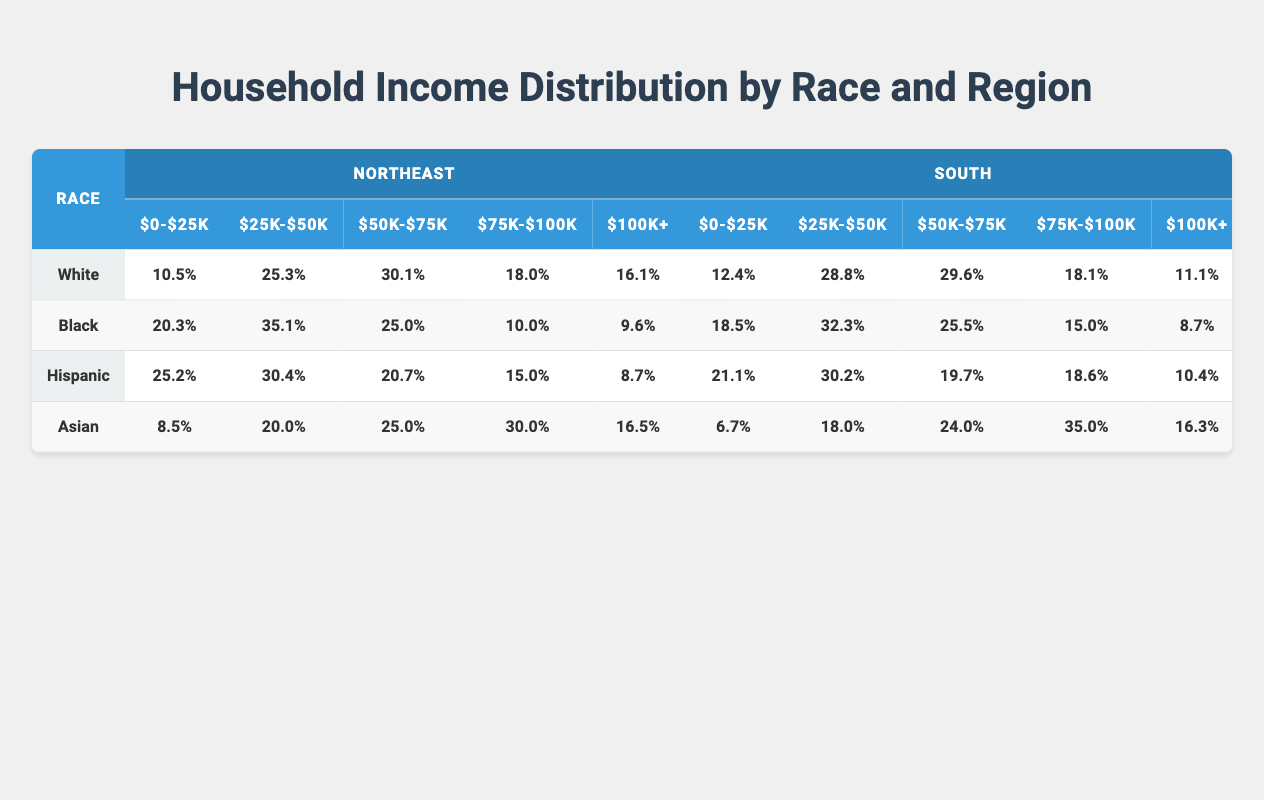What is the percentage of Black households earning $0-$25,000 in the Northeast? The table shows that Black households in the Northeast have a percentage of 20.3% in the $0-$25,000 income bracket.
Answer: 20.3% Which race in the Northeast has the highest percentage in the income bracket of $50,001-$75,000? Looking at the Northeast region, the White race has the highest percentage at 30.1% for the $50,001-$75,000 income bracket.
Answer: White What is the combined percentage of Hispanic and Black households earning $100,001 and above in the South? For Hispanic households, the percentage in the $100,001 and above bracket is 10.4%, and for Black households, it is 8.7%. Adding these figures gives 10.4 + 8.7 = 19.1%.
Answer: 19.1% Are there more Asian households in the South earning $75,001-$100,000 than White households? In the South, Asian households earn 35.0% in the $75,001-$100,000 bracket, while White households earn 18.1%. Comparing these percentages shows that there are indeed more Asian households in this income bracket.
Answer: Yes What is the total percentage of White households earning below $50,000 in the South? White households in the South have a percentage of 12.4% in the $0-$25,000 bracket and 28.8% in the $25,001-$50,000 bracket. Adding these gives 12.4 + 28.8 = 41.2%. Therefore, the total percentage is 41.2%.
Answer: 41.2% What percentage of Asian households in the Northeast earn more than $75,000? The table shows that Asian households in the Northeast have a percentage of 30.0% in the $75,001-$100,000 bracket and 16.5% in the $100,001 and above bracket. Therefore, adding these percentages gives 30.0 + 16.5 = 46.5%.
Answer: 46.5% How does the income distribution of Hispanic households earning between $25,001 and $50,000 compare in the Northeast and the South? In the Northeast, Hispanic households have a percentage of 30.4% in the $25,001-$50,000 bracket, while in the South, they have a percentage of 30.2%. The distribution is quite similar, with Northeast at 30.4% and South at 30.2%.
Answer: Similar What is the highest percentage of households earning $0-$25,000 among all races in the South? The highest percentage of households earning $0-$25,000 in the South is for Black households at 18.5%, which is higher than the percentages for White (12.4%), Hispanic (21.1%), and Asian (6.7%).
Answer: 18.5% 